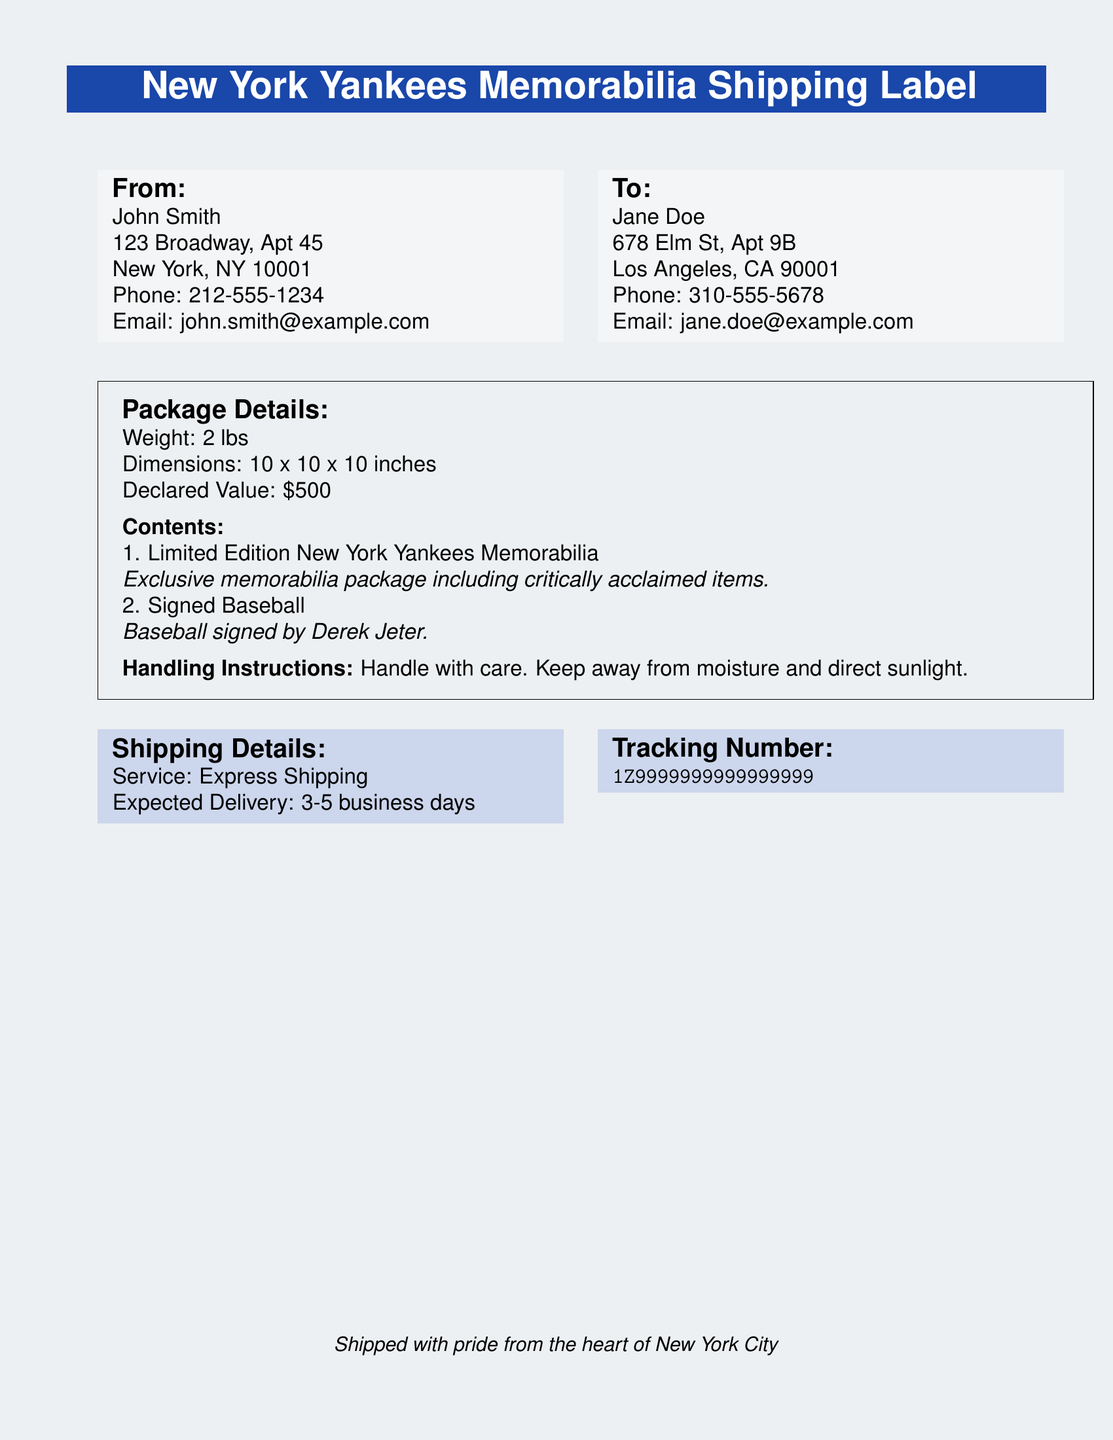what is the declared value of the package? The declared value is listed under the package details section of the document, indicating its worth.
Answer: $500 who is the sender of the package? The sender's name is specified in the "From" section of the document.
Answer: John Smith what is the weight of the package? The weight is noted in the package details, measuring the mass of the contents.
Answer: 2 lbs what is the expected delivery time for the package? The delivery time is provided under the shipping details section and indicates how long the package will take to reach the recipient.
Answer: 3-5 business days who is the recipient of the package? The recipient's name is found in the "To" section of the document.
Answer: Jane Doe what special handling instructions are mentioned? The handling instructions specify how the package should be treated during shipping and transit.
Answer: Handle with care what is the tracking number for the package? The tracking number is listed under the shipping details, allowing for tracking the package's progress.
Answer: 1Z9999999999999999 what type of memorabilia is included in the package? The type of memorabilia is detailed under the contents section of the package details.
Answer: Limited Edition New York Yankees Memorabilia who signed the baseball in the package? The signer of the baseball is specified in the package details, indicating its significance.
Answer: Derek Jeter 